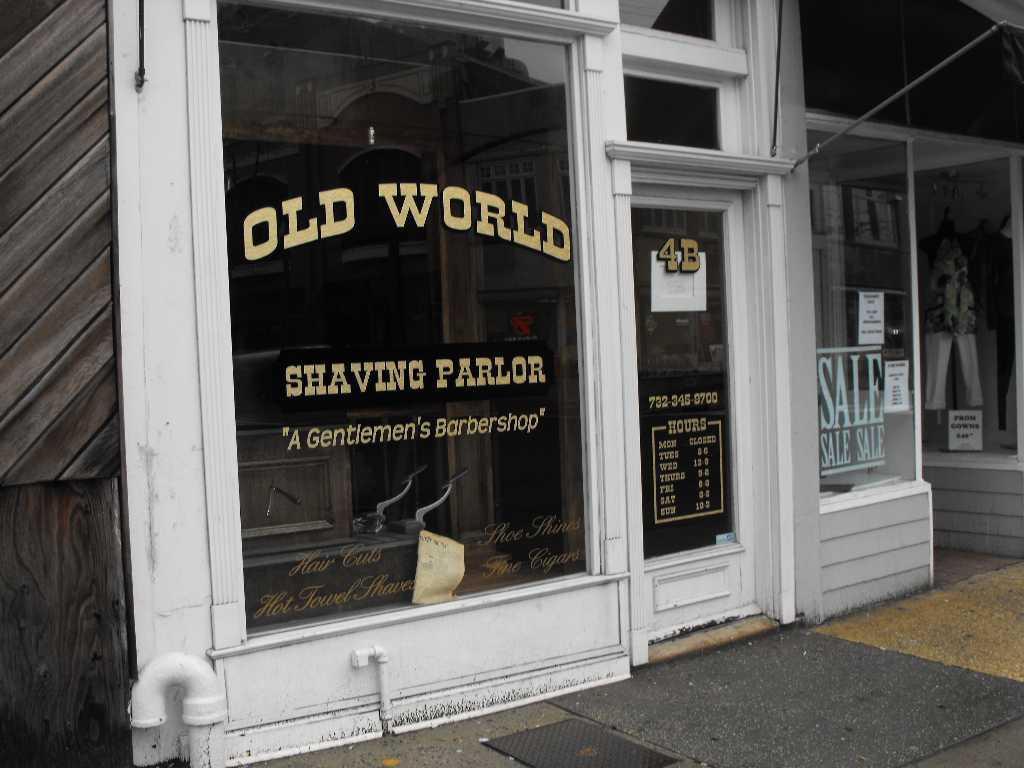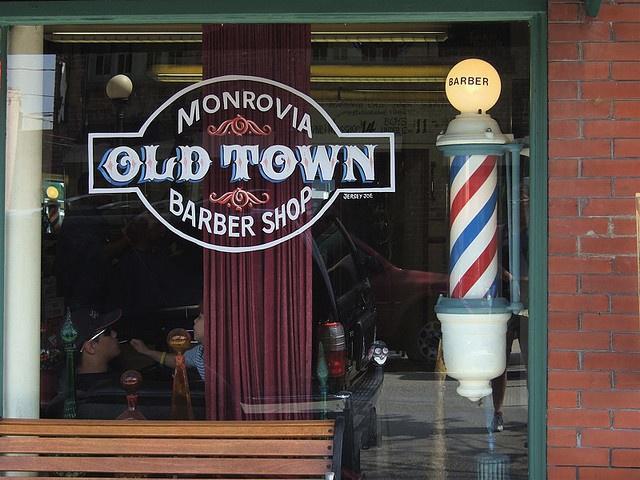The first image is the image on the left, the second image is the image on the right. Given the left and right images, does the statement "Each barber shop displays at least one barber pole." hold true? Answer yes or no. No. 